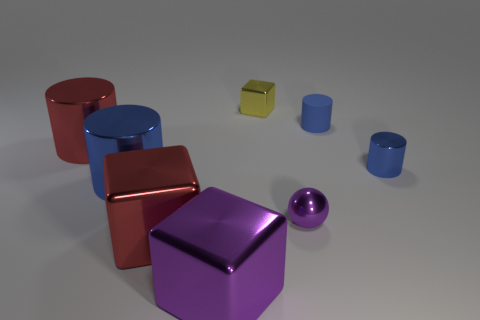Subtract all rubber cylinders. How many cylinders are left? 3 Add 2 yellow metallic cubes. How many objects exist? 10 Subtract all blue cylinders. How many cylinders are left? 1 Subtract 2 cylinders. How many cylinders are left? 2 Subtract all red blocks. Subtract all brown spheres. How many blocks are left? 2 Subtract all balls. How many objects are left? 7 Subtract all green cylinders. How many red blocks are left? 1 Add 4 yellow objects. How many yellow objects are left? 5 Add 6 yellow things. How many yellow things exist? 7 Subtract 0 brown spheres. How many objects are left? 8 